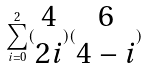Convert formula to latex. <formula><loc_0><loc_0><loc_500><loc_500>\sum _ { i = 0 } ^ { 2 } ( \begin{matrix} 4 \\ 2 i \end{matrix} ) ( \begin{matrix} 6 \\ 4 - i \end{matrix} )</formula> 